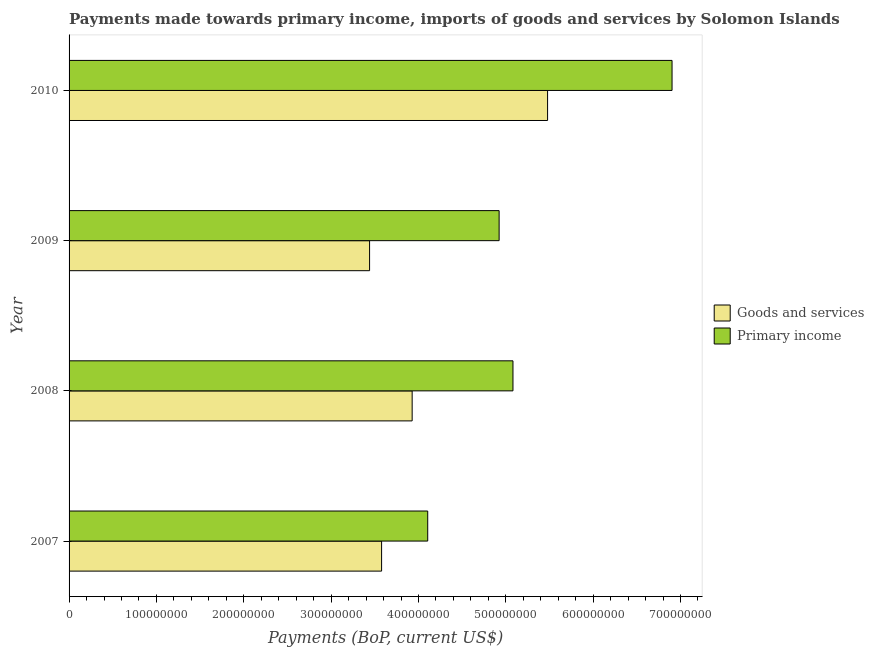How many bars are there on the 2nd tick from the bottom?
Your answer should be compact. 2. What is the label of the 3rd group of bars from the top?
Your response must be concise. 2008. What is the payments made towards primary income in 2009?
Give a very brief answer. 4.92e+08. Across all years, what is the maximum payments made towards primary income?
Provide a short and direct response. 6.90e+08. Across all years, what is the minimum payments made towards primary income?
Provide a succinct answer. 4.11e+08. What is the total payments made towards goods and services in the graph?
Your answer should be very brief. 1.64e+09. What is the difference between the payments made towards goods and services in 2007 and that in 2009?
Your response must be concise. 1.37e+07. What is the difference between the payments made towards goods and services in 2009 and the payments made towards primary income in 2008?
Your answer should be very brief. -1.64e+08. What is the average payments made towards primary income per year?
Your response must be concise. 5.25e+08. In the year 2010, what is the difference between the payments made towards primary income and payments made towards goods and services?
Make the answer very short. 1.42e+08. What is the ratio of the payments made towards goods and services in 2007 to that in 2008?
Your answer should be very brief. 0.91. Is the difference between the payments made towards primary income in 2009 and 2010 greater than the difference between the payments made towards goods and services in 2009 and 2010?
Offer a terse response. Yes. What is the difference between the highest and the second highest payments made towards goods and services?
Offer a very short reply. 1.55e+08. What is the difference between the highest and the lowest payments made towards primary income?
Your response must be concise. 2.80e+08. What does the 2nd bar from the top in 2010 represents?
Ensure brevity in your answer.  Goods and services. What does the 1st bar from the bottom in 2010 represents?
Offer a terse response. Goods and services. How many bars are there?
Offer a terse response. 8. Are the values on the major ticks of X-axis written in scientific E-notation?
Your answer should be very brief. No. Does the graph contain any zero values?
Your response must be concise. No. Does the graph contain grids?
Your answer should be compact. No. What is the title of the graph?
Your response must be concise. Payments made towards primary income, imports of goods and services by Solomon Islands. Does "Canada" appear as one of the legend labels in the graph?
Your response must be concise. No. What is the label or title of the X-axis?
Keep it short and to the point. Payments (BoP, current US$). What is the Payments (BoP, current US$) in Goods and services in 2007?
Ensure brevity in your answer.  3.58e+08. What is the Payments (BoP, current US$) in Primary income in 2007?
Make the answer very short. 4.11e+08. What is the Payments (BoP, current US$) of Goods and services in 2008?
Provide a short and direct response. 3.93e+08. What is the Payments (BoP, current US$) in Primary income in 2008?
Provide a short and direct response. 5.08e+08. What is the Payments (BoP, current US$) of Goods and services in 2009?
Your response must be concise. 3.44e+08. What is the Payments (BoP, current US$) in Primary income in 2009?
Provide a short and direct response. 4.92e+08. What is the Payments (BoP, current US$) of Goods and services in 2010?
Provide a short and direct response. 5.48e+08. What is the Payments (BoP, current US$) of Primary income in 2010?
Ensure brevity in your answer.  6.90e+08. Across all years, what is the maximum Payments (BoP, current US$) in Goods and services?
Your response must be concise. 5.48e+08. Across all years, what is the maximum Payments (BoP, current US$) in Primary income?
Your answer should be compact. 6.90e+08. Across all years, what is the minimum Payments (BoP, current US$) in Goods and services?
Keep it short and to the point. 3.44e+08. Across all years, what is the minimum Payments (BoP, current US$) in Primary income?
Provide a succinct answer. 4.11e+08. What is the total Payments (BoP, current US$) of Goods and services in the graph?
Your answer should be very brief. 1.64e+09. What is the total Payments (BoP, current US$) of Primary income in the graph?
Provide a short and direct response. 2.10e+09. What is the difference between the Payments (BoP, current US$) in Goods and services in 2007 and that in 2008?
Ensure brevity in your answer.  -3.50e+07. What is the difference between the Payments (BoP, current US$) of Primary income in 2007 and that in 2008?
Your answer should be compact. -9.76e+07. What is the difference between the Payments (BoP, current US$) of Goods and services in 2007 and that in 2009?
Ensure brevity in your answer.  1.37e+07. What is the difference between the Payments (BoP, current US$) of Primary income in 2007 and that in 2009?
Provide a short and direct response. -8.17e+07. What is the difference between the Payments (BoP, current US$) of Goods and services in 2007 and that in 2010?
Ensure brevity in your answer.  -1.90e+08. What is the difference between the Payments (BoP, current US$) of Primary income in 2007 and that in 2010?
Make the answer very short. -2.80e+08. What is the difference between the Payments (BoP, current US$) in Goods and services in 2008 and that in 2009?
Your answer should be compact. 4.87e+07. What is the difference between the Payments (BoP, current US$) in Primary income in 2008 and that in 2009?
Keep it short and to the point. 1.58e+07. What is the difference between the Payments (BoP, current US$) in Goods and services in 2008 and that in 2010?
Make the answer very short. -1.55e+08. What is the difference between the Payments (BoP, current US$) in Primary income in 2008 and that in 2010?
Your response must be concise. -1.82e+08. What is the difference between the Payments (BoP, current US$) of Goods and services in 2009 and that in 2010?
Keep it short and to the point. -2.04e+08. What is the difference between the Payments (BoP, current US$) in Primary income in 2009 and that in 2010?
Provide a short and direct response. -1.98e+08. What is the difference between the Payments (BoP, current US$) in Goods and services in 2007 and the Payments (BoP, current US$) in Primary income in 2008?
Your answer should be very brief. -1.50e+08. What is the difference between the Payments (BoP, current US$) of Goods and services in 2007 and the Payments (BoP, current US$) of Primary income in 2009?
Provide a short and direct response. -1.35e+08. What is the difference between the Payments (BoP, current US$) in Goods and services in 2007 and the Payments (BoP, current US$) in Primary income in 2010?
Offer a very short reply. -3.33e+08. What is the difference between the Payments (BoP, current US$) of Goods and services in 2008 and the Payments (BoP, current US$) of Primary income in 2009?
Your answer should be very brief. -9.96e+07. What is the difference between the Payments (BoP, current US$) of Goods and services in 2008 and the Payments (BoP, current US$) of Primary income in 2010?
Provide a succinct answer. -2.98e+08. What is the difference between the Payments (BoP, current US$) in Goods and services in 2009 and the Payments (BoP, current US$) in Primary income in 2010?
Keep it short and to the point. -3.46e+08. What is the average Payments (BoP, current US$) in Goods and services per year?
Keep it short and to the point. 4.11e+08. What is the average Payments (BoP, current US$) of Primary income per year?
Your response must be concise. 5.25e+08. In the year 2007, what is the difference between the Payments (BoP, current US$) in Goods and services and Payments (BoP, current US$) in Primary income?
Your response must be concise. -5.28e+07. In the year 2008, what is the difference between the Payments (BoP, current US$) of Goods and services and Payments (BoP, current US$) of Primary income?
Your response must be concise. -1.15e+08. In the year 2009, what is the difference between the Payments (BoP, current US$) in Goods and services and Payments (BoP, current US$) in Primary income?
Your response must be concise. -1.48e+08. In the year 2010, what is the difference between the Payments (BoP, current US$) of Goods and services and Payments (BoP, current US$) of Primary income?
Your response must be concise. -1.42e+08. What is the ratio of the Payments (BoP, current US$) of Goods and services in 2007 to that in 2008?
Provide a short and direct response. 0.91. What is the ratio of the Payments (BoP, current US$) in Primary income in 2007 to that in 2008?
Your response must be concise. 0.81. What is the ratio of the Payments (BoP, current US$) in Primary income in 2007 to that in 2009?
Keep it short and to the point. 0.83. What is the ratio of the Payments (BoP, current US$) of Goods and services in 2007 to that in 2010?
Provide a succinct answer. 0.65. What is the ratio of the Payments (BoP, current US$) of Primary income in 2007 to that in 2010?
Make the answer very short. 0.59. What is the ratio of the Payments (BoP, current US$) in Goods and services in 2008 to that in 2009?
Offer a very short reply. 1.14. What is the ratio of the Payments (BoP, current US$) in Primary income in 2008 to that in 2009?
Provide a short and direct response. 1.03. What is the ratio of the Payments (BoP, current US$) in Goods and services in 2008 to that in 2010?
Your answer should be very brief. 0.72. What is the ratio of the Payments (BoP, current US$) of Primary income in 2008 to that in 2010?
Give a very brief answer. 0.74. What is the ratio of the Payments (BoP, current US$) of Goods and services in 2009 to that in 2010?
Provide a succinct answer. 0.63. What is the ratio of the Payments (BoP, current US$) in Primary income in 2009 to that in 2010?
Your answer should be very brief. 0.71. What is the difference between the highest and the second highest Payments (BoP, current US$) in Goods and services?
Offer a terse response. 1.55e+08. What is the difference between the highest and the second highest Payments (BoP, current US$) of Primary income?
Offer a very short reply. 1.82e+08. What is the difference between the highest and the lowest Payments (BoP, current US$) in Goods and services?
Ensure brevity in your answer.  2.04e+08. What is the difference between the highest and the lowest Payments (BoP, current US$) of Primary income?
Provide a short and direct response. 2.80e+08. 